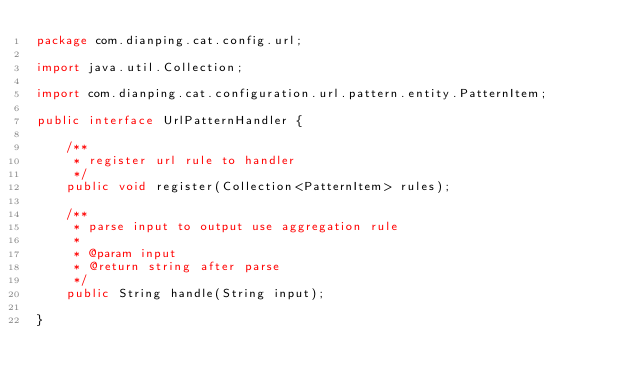Convert code to text. <code><loc_0><loc_0><loc_500><loc_500><_Java_>package com.dianping.cat.config.url;

import java.util.Collection;

import com.dianping.cat.configuration.url.pattern.entity.PatternItem;

public interface UrlPatternHandler {

	/**
	 * register url rule to handler
	 */
	public void register(Collection<PatternItem> rules);

	/**
	 * parse input to output use aggregation rule
	 * 
	 * @param input
	 * @return string after parse
	 */
	public String handle(String input);

}
</code> 